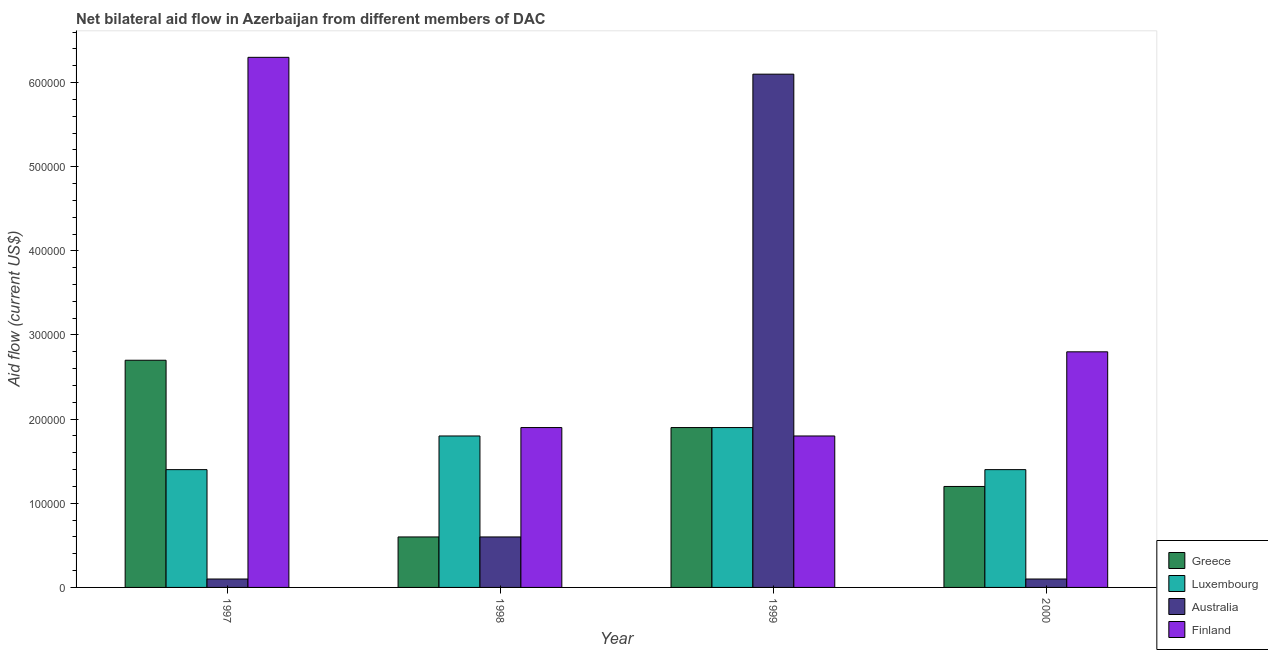How many different coloured bars are there?
Your answer should be very brief. 4. Are the number of bars per tick equal to the number of legend labels?
Offer a terse response. Yes. Are the number of bars on each tick of the X-axis equal?
Provide a succinct answer. Yes. What is the label of the 3rd group of bars from the left?
Give a very brief answer. 1999. In how many cases, is the number of bars for a given year not equal to the number of legend labels?
Ensure brevity in your answer.  0. What is the amount of aid given by finland in 2000?
Offer a terse response. 2.80e+05. Across all years, what is the maximum amount of aid given by luxembourg?
Keep it short and to the point. 1.90e+05. Across all years, what is the minimum amount of aid given by greece?
Provide a short and direct response. 6.00e+04. In which year was the amount of aid given by australia minimum?
Make the answer very short. 1997. What is the total amount of aid given by finland in the graph?
Give a very brief answer. 1.28e+06. What is the difference between the amount of aid given by finland in 1997 and that in 1998?
Your answer should be very brief. 4.40e+05. What is the difference between the amount of aid given by finland in 1998 and the amount of aid given by greece in 1999?
Ensure brevity in your answer.  10000. What is the average amount of aid given by finland per year?
Your response must be concise. 3.20e+05. In how many years, is the amount of aid given by australia greater than 140000 US$?
Your answer should be compact. 1. What is the ratio of the amount of aid given by luxembourg in 1999 to that in 2000?
Make the answer very short. 1.36. Is the amount of aid given by greece in 1998 less than that in 2000?
Make the answer very short. Yes. What is the difference between the highest and the lowest amount of aid given by finland?
Make the answer very short. 4.50e+05. In how many years, is the amount of aid given by australia greater than the average amount of aid given by australia taken over all years?
Give a very brief answer. 1. Is it the case that in every year, the sum of the amount of aid given by luxembourg and amount of aid given by finland is greater than the sum of amount of aid given by greece and amount of aid given by australia?
Keep it short and to the point. Yes. What does the 1st bar from the left in 1997 represents?
Offer a very short reply. Greece. What does the 3rd bar from the right in 2000 represents?
Provide a short and direct response. Luxembourg. Is it the case that in every year, the sum of the amount of aid given by greece and amount of aid given by luxembourg is greater than the amount of aid given by australia?
Your answer should be very brief. No. How many bars are there?
Offer a terse response. 16. What is the difference between two consecutive major ticks on the Y-axis?
Provide a short and direct response. 1.00e+05. Does the graph contain grids?
Give a very brief answer. No. What is the title of the graph?
Your response must be concise. Net bilateral aid flow in Azerbaijan from different members of DAC. What is the label or title of the Y-axis?
Offer a very short reply. Aid flow (current US$). What is the Aid flow (current US$) in Greece in 1997?
Your answer should be very brief. 2.70e+05. What is the Aid flow (current US$) in Finland in 1997?
Give a very brief answer. 6.30e+05. What is the Aid flow (current US$) of Luxembourg in 1999?
Make the answer very short. 1.90e+05. What is the Aid flow (current US$) in Greece in 2000?
Offer a very short reply. 1.20e+05. What is the Aid flow (current US$) in Luxembourg in 2000?
Give a very brief answer. 1.40e+05. What is the Aid flow (current US$) of Australia in 2000?
Ensure brevity in your answer.  10000. What is the Aid flow (current US$) of Finland in 2000?
Your answer should be compact. 2.80e+05. Across all years, what is the maximum Aid flow (current US$) of Greece?
Provide a succinct answer. 2.70e+05. Across all years, what is the maximum Aid flow (current US$) of Finland?
Offer a very short reply. 6.30e+05. Across all years, what is the minimum Aid flow (current US$) of Luxembourg?
Provide a succinct answer. 1.40e+05. Across all years, what is the minimum Aid flow (current US$) of Australia?
Your answer should be compact. 10000. Across all years, what is the minimum Aid flow (current US$) of Finland?
Keep it short and to the point. 1.80e+05. What is the total Aid flow (current US$) of Greece in the graph?
Provide a short and direct response. 6.40e+05. What is the total Aid flow (current US$) of Luxembourg in the graph?
Offer a terse response. 6.50e+05. What is the total Aid flow (current US$) in Australia in the graph?
Make the answer very short. 6.90e+05. What is the total Aid flow (current US$) in Finland in the graph?
Offer a terse response. 1.28e+06. What is the difference between the Aid flow (current US$) of Luxembourg in 1997 and that in 1998?
Give a very brief answer. -4.00e+04. What is the difference between the Aid flow (current US$) of Finland in 1997 and that in 1998?
Offer a very short reply. 4.40e+05. What is the difference between the Aid flow (current US$) in Greece in 1997 and that in 1999?
Provide a short and direct response. 8.00e+04. What is the difference between the Aid flow (current US$) of Australia in 1997 and that in 1999?
Your answer should be very brief. -6.00e+05. What is the difference between the Aid flow (current US$) in Greece in 1997 and that in 2000?
Offer a very short reply. 1.50e+05. What is the difference between the Aid flow (current US$) in Greece in 1998 and that in 1999?
Give a very brief answer. -1.30e+05. What is the difference between the Aid flow (current US$) of Australia in 1998 and that in 1999?
Your answer should be very brief. -5.50e+05. What is the difference between the Aid flow (current US$) of Australia in 1999 and that in 2000?
Give a very brief answer. 6.00e+05. What is the difference between the Aid flow (current US$) of Finland in 1999 and that in 2000?
Your response must be concise. -1.00e+05. What is the difference between the Aid flow (current US$) in Greece in 1997 and the Aid flow (current US$) in Luxembourg in 1998?
Keep it short and to the point. 9.00e+04. What is the difference between the Aid flow (current US$) in Greece in 1997 and the Aid flow (current US$) in Australia in 1998?
Provide a short and direct response. 2.10e+05. What is the difference between the Aid flow (current US$) in Luxembourg in 1997 and the Aid flow (current US$) in Australia in 1998?
Your response must be concise. 8.00e+04. What is the difference between the Aid flow (current US$) in Luxembourg in 1997 and the Aid flow (current US$) in Finland in 1998?
Keep it short and to the point. -5.00e+04. What is the difference between the Aid flow (current US$) of Greece in 1997 and the Aid flow (current US$) of Australia in 1999?
Make the answer very short. -3.40e+05. What is the difference between the Aid flow (current US$) in Greece in 1997 and the Aid flow (current US$) in Finland in 1999?
Offer a terse response. 9.00e+04. What is the difference between the Aid flow (current US$) in Luxembourg in 1997 and the Aid flow (current US$) in Australia in 1999?
Offer a very short reply. -4.70e+05. What is the difference between the Aid flow (current US$) in Luxembourg in 1997 and the Aid flow (current US$) in Finland in 1999?
Ensure brevity in your answer.  -4.00e+04. What is the difference between the Aid flow (current US$) in Australia in 1997 and the Aid flow (current US$) in Finland in 1999?
Keep it short and to the point. -1.70e+05. What is the difference between the Aid flow (current US$) in Greece in 1997 and the Aid flow (current US$) in Luxembourg in 2000?
Provide a short and direct response. 1.30e+05. What is the difference between the Aid flow (current US$) of Greece in 1997 and the Aid flow (current US$) of Finland in 2000?
Your response must be concise. -10000. What is the difference between the Aid flow (current US$) in Luxembourg in 1997 and the Aid flow (current US$) in Australia in 2000?
Provide a short and direct response. 1.30e+05. What is the difference between the Aid flow (current US$) of Luxembourg in 1997 and the Aid flow (current US$) of Finland in 2000?
Keep it short and to the point. -1.40e+05. What is the difference between the Aid flow (current US$) in Greece in 1998 and the Aid flow (current US$) in Luxembourg in 1999?
Offer a terse response. -1.30e+05. What is the difference between the Aid flow (current US$) in Greece in 1998 and the Aid flow (current US$) in Australia in 1999?
Make the answer very short. -5.50e+05. What is the difference between the Aid flow (current US$) of Luxembourg in 1998 and the Aid flow (current US$) of Australia in 1999?
Ensure brevity in your answer.  -4.30e+05. What is the difference between the Aid flow (current US$) of Australia in 1998 and the Aid flow (current US$) of Finland in 1999?
Give a very brief answer. -1.20e+05. What is the difference between the Aid flow (current US$) in Greece in 1998 and the Aid flow (current US$) in Australia in 2000?
Give a very brief answer. 5.00e+04. What is the difference between the Aid flow (current US$) of Greece in 1998 and the Aid flow (current US$) of Finland in 2000?
Keep it short and to the point. -2.20e+05. What is the difference between the Aid flow (current US$) of Luxembourg in 1998 and the Aid flow (current US$) of Finland in 2000?
Ensure brevity in your answer.  -1.00e+05. What is the difference between the Aid flow (current US$) in Luxembourg in 1999 and the Aid flow (current US$) in Australia in 2000?
Provide a short and direct response. 1.80e+05. What is the average Aid flow (current US$) in Greece per year?
Provide a succinct answer. 1.60e+05. What is the average Aid flow (current US$) of Luxembourg per year?
Provide a short and direct response. 1.62e+05. What is the average Aid flow (current US$) in Australia per year?
Offer a very short reply. 1.72e+05. In the year 1997, what is the difference between the Aid flow (current US$) in Greece and Aid flow (current US$) in Finland?
Offer a very short reply. -3.60e+05. In the year 1997, what is the difference between the Aid flow (current US$) of Luxembourg and Aid flow (current US$) of Finland?
Offer a terse response. -4.90e+05. In the year 1997, what is the difference between the Aid flow (current US$) of Australia and Aid flow (current US$) of Finland?
Ensure brevity in your answer.  -6.20e+05. In the year 1998, what is the difference between the Aid flow (current US$) in Greece and Aid flow (current US$) in Luxembourg?
Keep it short and to the point. -1.20e+05. In the year 1998, what is the difference between the Aid flow (current US$) in Greece and Aid flow (current US$) in Finland?
Offer a very short reply. -1.30e+05. In the year 1999, what is the difference between the Aid flow (current US$) of Greece and Aid flow (current US$) of Luxembourg?
Ensure brevity in your answer.  0. In the year 1999, what is the difference between the Aid flow (current US$) of Greece and Aid flow (current US$) of Australia?
Your answer should be very brief. -4.20e+05. In the year 1999, what is the difference between the Aid flow (current US$) of Greece and Aid flow (current US$) of Finland?
Give a very brief answer. 10000. In the year 1999, what is the difference between the Aid flow (current US$) in Luxembourg and Aid flow (current US$) in Australia?
Keep it short and to the point. -4.20e+05. In the year 1999, what is the difference between the Aid flow (current US$) in Luxembourg and Aid flow (current US$) in Finland?
Offer a terse response. 10000. In the year 1999, what is the difference between the Aid flow (current US$) in Australia and Aid flow (current US$) in Finland?
Keep it short and to the point. 4.30e+05. In the year 2000, what is the difference between the Aid flow (current US$) in Greece and Aid flow (current US$) in Luxembourg?
Offer a terse response. -2.00e+04. In the year 2000, what is the difference between the Aid flow (current US$) of Greece and Aid flow (current US$) of Finland?
Provide a short and direct response. -1.60e+05. In the year 2000, what is the difference between the Aid flow (current US$) in Luxembourg and Aid flow (current US$) in Australia?
Keep it short and to the point. 1.30e+05. In the year 2000, what is the difference between the Aid flow (current US$) in Luxembourg and Aid flow (current US$) in Finland?
Your answer should be compact. -1.40e+05. In the year 2000, what is the difference between the Aid flow (current US$) in Australia and Aid flow (current US$) in Finland?
Ensure brevity in your answer.  -2.70e+05. What is the ratio of the Aid flow (current US$) in Greece in 1997 to that in 1998?
Your response must be concise. 4.5. What is the ratio of the Aid flow (current US$) in Luxembourg in 1997 to that in 1998?
Ensure brevity in your answer.  0.78. What is the ratio of the Aid flow (current US$) in Australia in 1997 to that in 1998?
Your answer should be very brief. 0.17. What is the ratio of the Aid flow (current US$) of Finland in 1997 to that in 1998?
Keep it short and to the point. 3.32. What is the ratio of the Aid flow (current US$) of Greece in 1997 to that in 1999?
Provide a succinct answer. 1.42. What is the ratio of the Aid flow (current US$) in Luxembourg in 1997 to that in 1999?
Provide a succinct answer. 0.74. What is the ratio of the Aid flow (current US$) in Australia in 1997 to that in 1999?
Give a very brief answer. 0.02. What is the ratio of the Aid flow (current US$) in Greece in 1997 to that in 2000?
Your answer should be compact. 2.25. What is the ratio of the Aid flow (current US$) of Luxembourg in 1997 to that in 2000?
Your answer should be compact. 1. What is the ratio of the Aid flow (current US$) of Australia in 1997 to that in 2000?
Offer a very short reply. 1. What is the ratio of the Aid flow (current US$) in Finland in 1997 to that in 2000?
Your answer should be very brief. 2.25. What is the ratio of the Aid flow (current US$) in Greece in 1998 to that in 1999?
Give a very brief answer. 0.32. What is the ratio of the Aid flow (current US$) of Luxembourg in 1998 to that in 1999?
Provide a succinct answer. 0.95. What is the ratio of the Aid flow (current US$) in Australia in 1998 to that in 1999?
Provide a succinct answer. 0.1. What is the ratio of the Aid flow (current US$) of Finland in 1998 to that in 1999?
Your answer should be compact. 1.06. What is the ratio of the Aid flow (current US$) in Greece in 1998 to that in 2000?
Your answer should be very brief. 0.5. What is the ratio of the Aid flow (current US$) of Luxembourg in 1998 to that in 2000?
Your answer should be very brief. 1.29. What is the ratio of the Aid flow (current US$) of Australia in 1998 to that in 2000?
Ensure brevity in your answer.  6. What is the ratio of the Aid flow (current US$) of Finland in 1998 to that in 2000?
Your answer should be very brief. 0.68. What is the ratio of the Aid flow (current US$) in Greece in 1999 to that in 2000?
Your answer should be very brief. 1.58. What is the ratio of the Aid flow (current US$) in Luxembourg in 1999 to that in 2000?
Your answer should be compact. 1.36. What is the ratio of the Aid flow (current US$) in Australia in 1999 to that in 2000?
Offer a terse response. 61. What is the ratio of the Aid flow (current US$) in Finland in 1999 to that in 2000?
Your answer should be very brief. 0.64. What is the difference between the highest and the second highest Aid flow (current US$) in Luxembourg?
Your response must be concise. 10000. What is the difference between the highest and the lowest Aid flow (current US$) in Luxembourg?
Provide a short and direct response. 5.00e+04. 